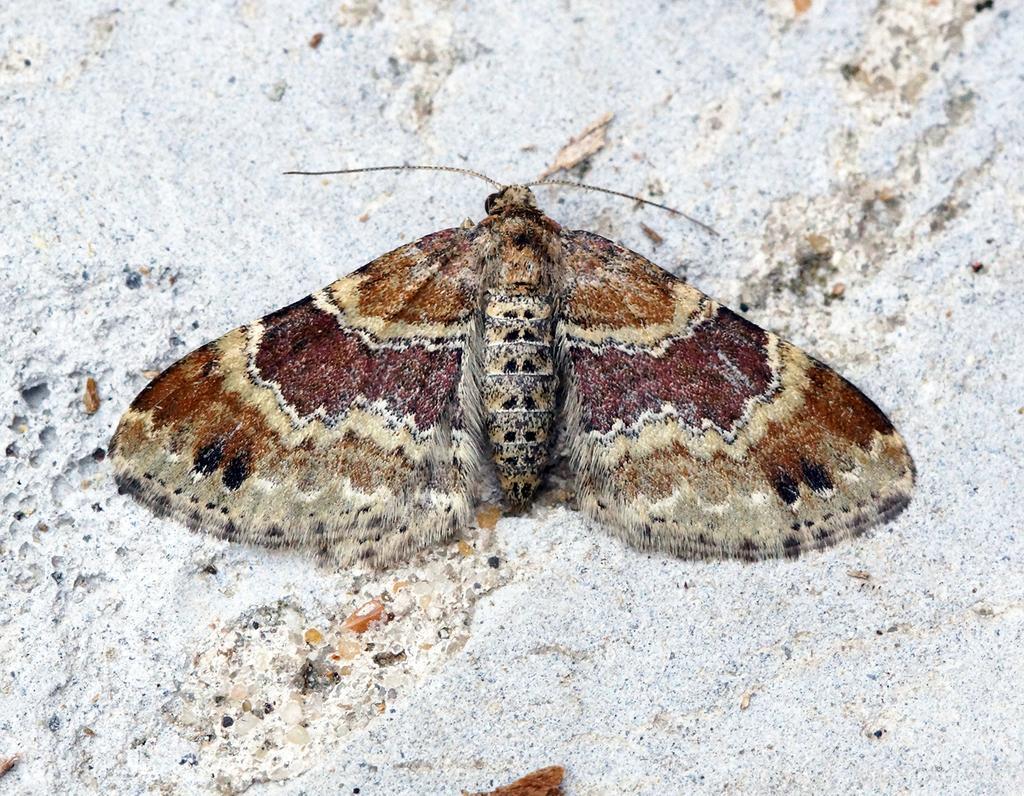Please provide a concise description of this image. In this image, we can see a butterfly on the white colored surface. 